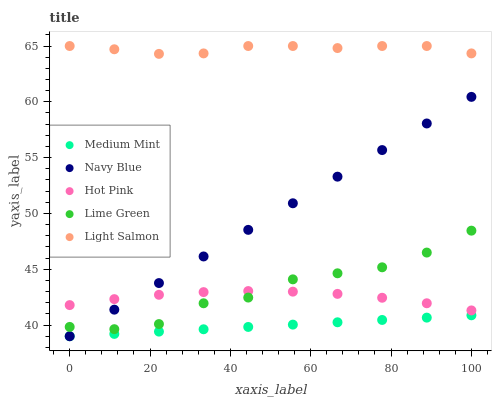Does Medium Mint have the minimum area under the curve?
Answer yes or no. Yes. Does Light Salmon have the maximum area under the curve?
Answer yes or no. Yes. Does Navy Blue have the minimum area under the curve?
Answer yes or no. No. Does Navy Blue have the maximum area under the curve?
Answer yes or no. No. Is Navy Blue the smoothest?
Answer yes or no. Yes. Is Lime Green the roughest?
Answer yes or no. Yes. Is Light Salmon the smoothest?
Answer yes or no. No. Is Light Salmon the roughest?
Answer yes or no. No. Does Medium Mint have the lowest value?
Answer yes or no. Yes. Does Light Salmon have the lowest value?
Answer yes or no. No. Does Light Salmon have the highest value?
Answer yes or no. Yes. Does Navy Blue have the highest value?
Answer yes or no. No. Is Medium Mint less than Lime Green?
Answer yes or no. Yes. Is Light Salmon greater than Hot Pink?
Answer yes or no. Yes. Does Lime Green intersect Navy Blue?
Answer yes or no. Yes. Is Lime Green less than Navy Blue?
Answer yes or no. No. Is Lime Green greater than Navy Blue?
Answer yes or no. No. Does Medium Mint intersect Lime Green?
Answer yes or no. No. 